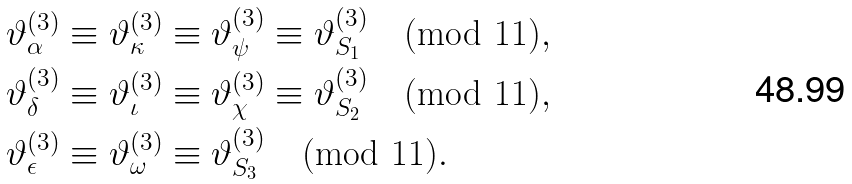<formula> <loc_0><loc_0><loc_500><loc_500>& \vartheta _ { \alpha } ^ { ( 3 ) } \equiv \vartheta _ { \kappa } ^ { ( 3 ) } \equiv \vartheta _ { \psi } ^ { ( 3 ) } \equiv \vartheta _ { S _ { 1 } } ^ { ( 3 ) } \pmod { 1 1 } , \\ & \vartheta _ { \delta } ^ { ( 3 ) } \equiv \vartheta _ { \iota } ^ { ( 3 ) } \equiv \vartheta _ { \chi } ^ { ( 3 ) } \equiv \vartheta _ { S _ { 2 } } ^ { ( 3 ) } \pmod { 1 1 } , \\ & \vartheta _ { \epsilon } ^ { ( 3 ) } \equiv \vartheta _ { \omega } ^ { ( 3 ) } \equiv \vartheta _ { S _ { 3 } } ^ { ( 3 ) } \pmod { 1 1 } .</formula> 